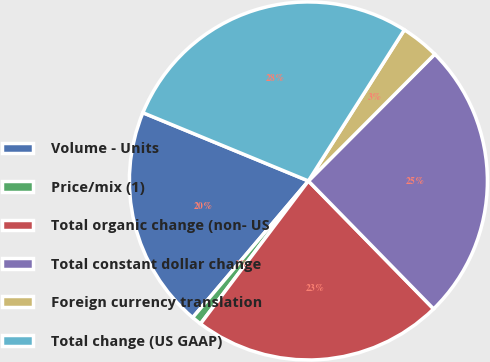<chart> <loc_0><loc_0><loc_500><loc_500><pie_chart><fcel>Volume - Units<fcel>Price/mix (1)<fcel>Total organic change (non- US<fcel>Total constant dollar change<fcel>Foreign currency translation<fcel>Total change (US GAAP)<nl><fcel>20.04%<fcel>0.89%<fcel>22.62%<fcel>25.2%<fcel>3.47%<fcel>27.78%<nl></chart> 